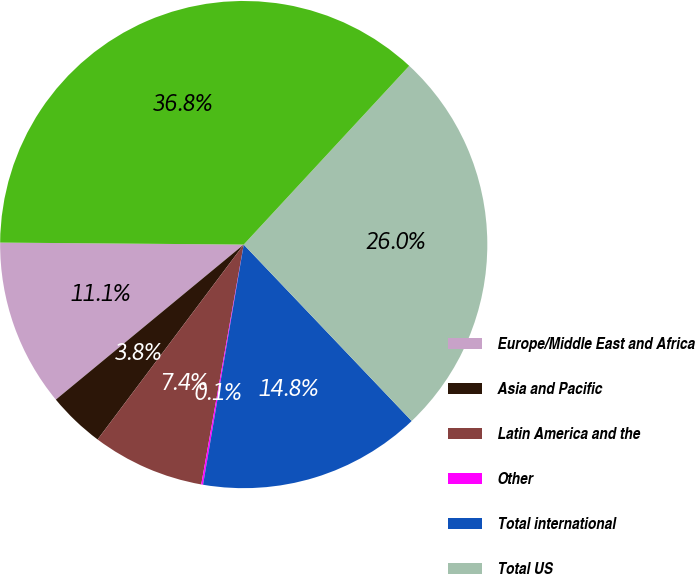Convert chart. <chart><loc_0><loc_0><loc_500><loc_500><pie_chart><fcel>Europe/Middle East and Africa<fcel>Asia and Pacific<fcel>Latin America and the<fcel>Other<fcel>Total international<fcel>Total US<fcel>Total<nl><fcel>11.11%<fcel>3.78%<fcel>7.45%<fcel>0.12%<fcel>14.78%<fcel>26.0%<fcel>36.76%<nl></chart> 